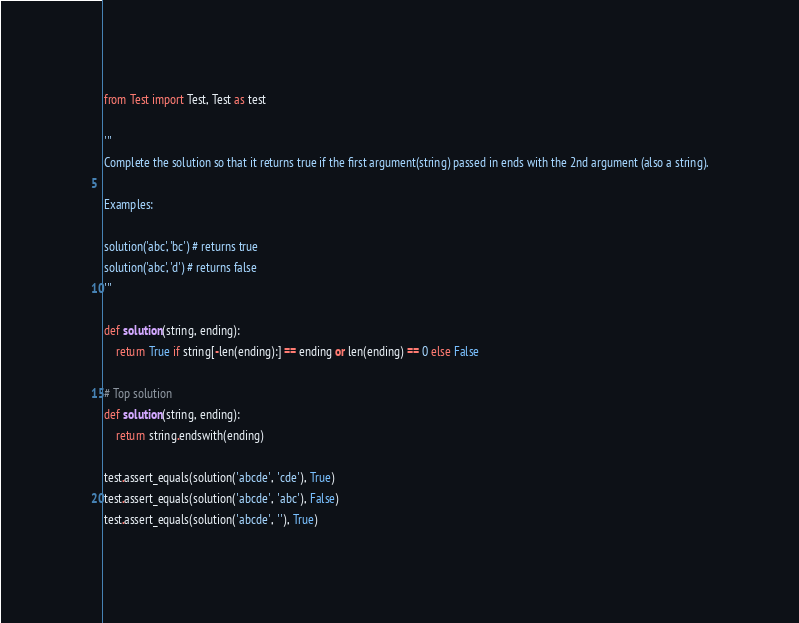Convert code to text. <code><loc_0><loc_0><loc_500><loc_500><_Python_>from Test import Test, Test as test

'''
Complete the solution so that it returns true if the first argument(string) passed in ends with the 2nd argument (also a string).

Examples:

solution('abc', 'bc') # returns true
solution('abc', 'd') # returns false
'''

def solution(string, ending):
    return True if string[-len(ending):] == ending or len(ending) == 0 else False

# Top solution
def solution(string, ending):
    return string.endswith(ending)

test.assert_equals(solution('abcde', 'cde'), True)
test.assert_equals(solution('abcde', 'abc'), False)
test.assert_equals(solution('abcde', ''), True)</code> 